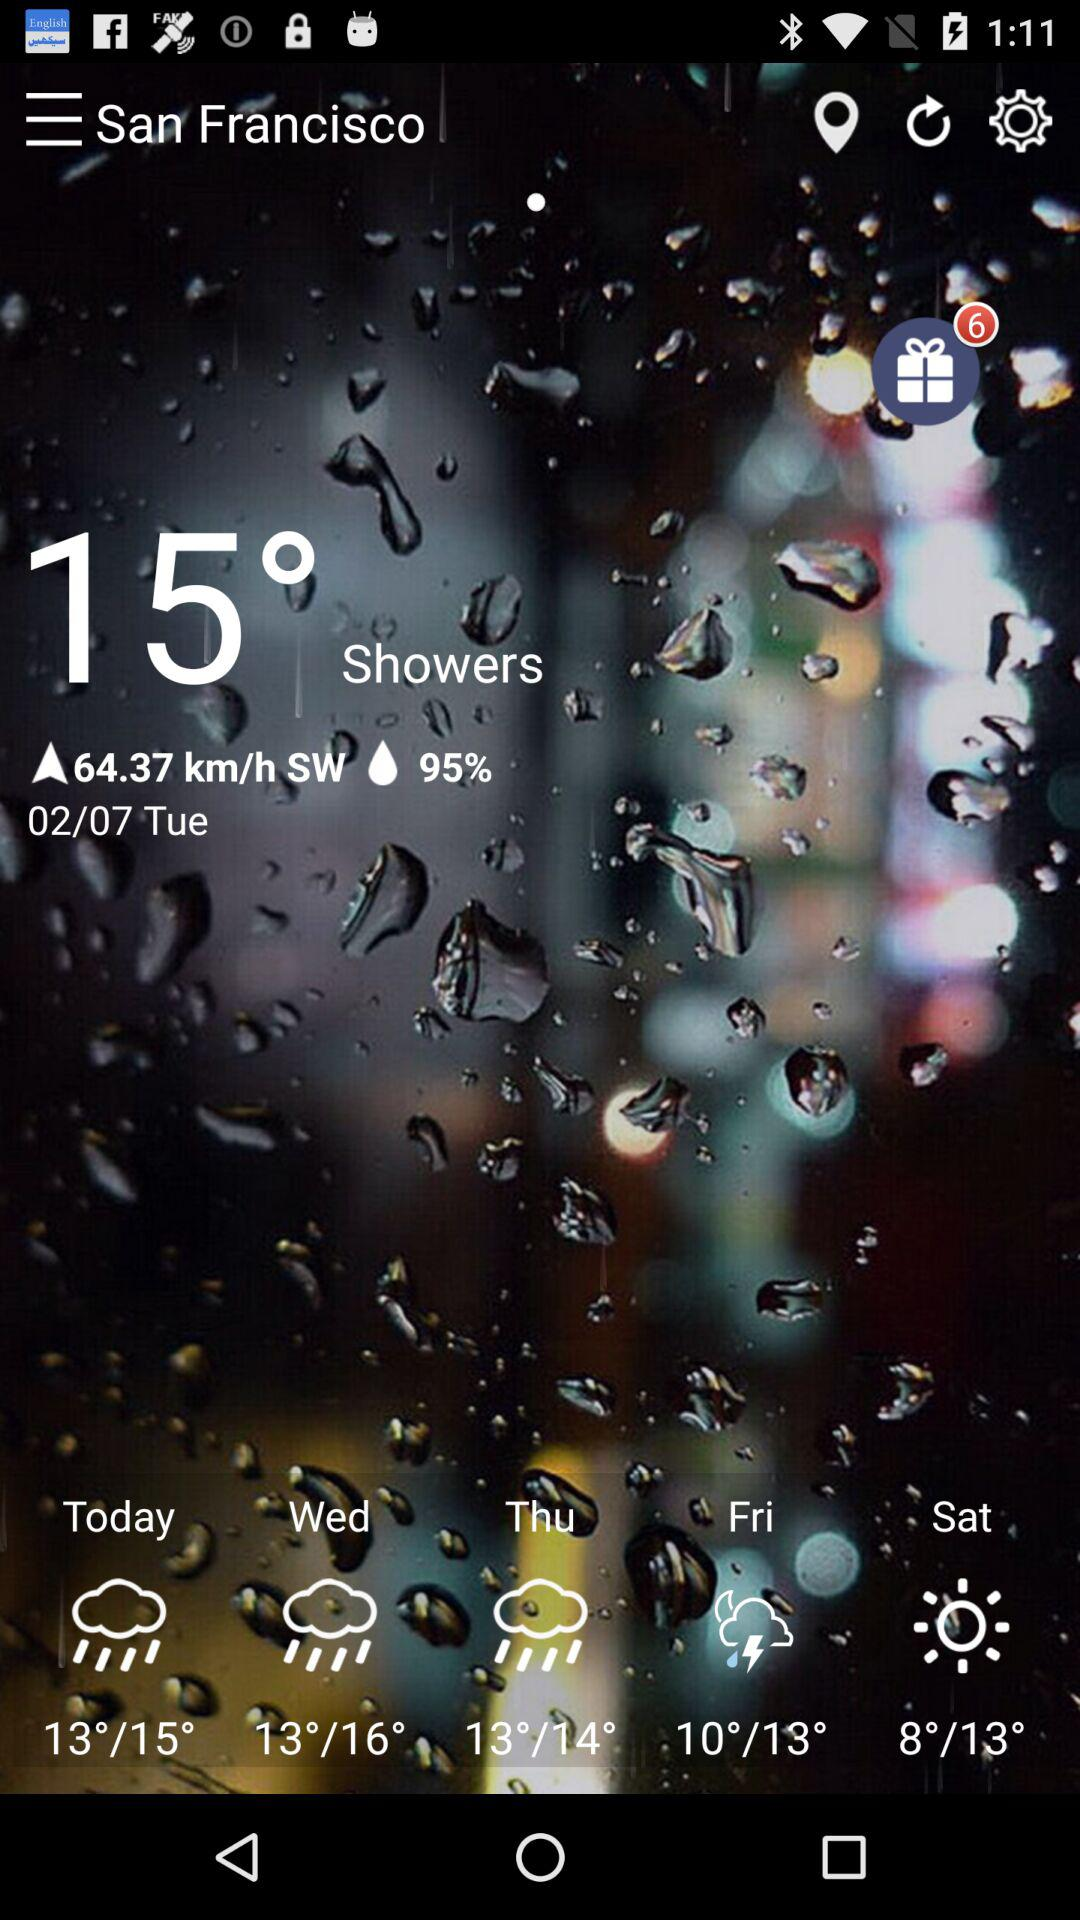How many gifts are there? There are 6 gifts. 